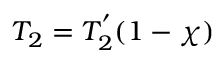<formula> <loc_0><loc_0><loc_500><loc_500>T _ { 2 } = T _ { 2 } ^ { ^ { \prime } } ( 1 - \chi )</formula> 